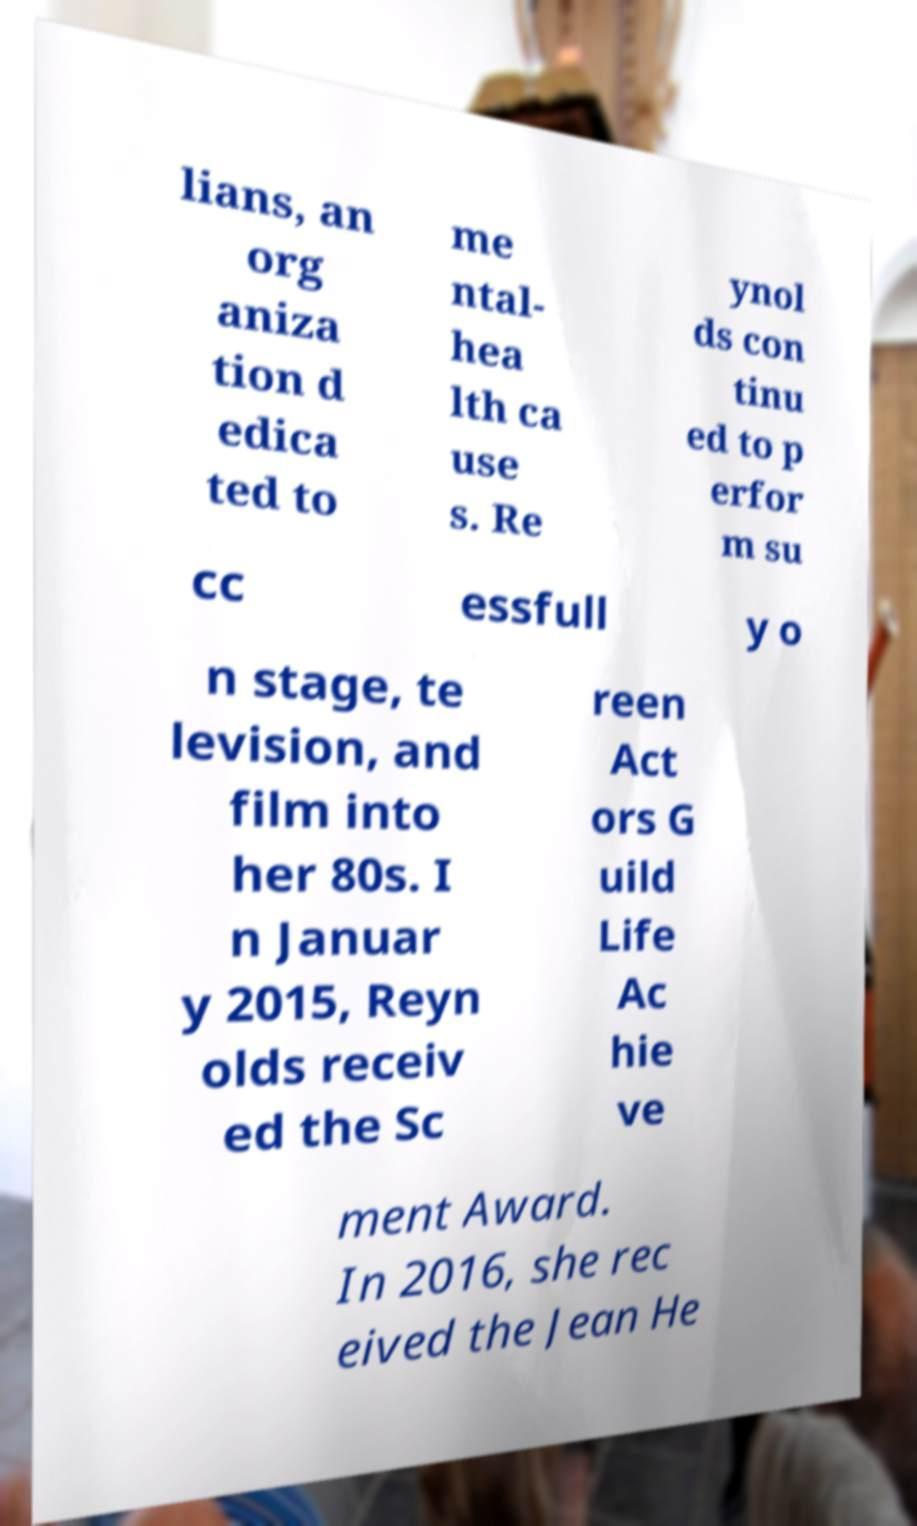I need the written content from this picture converted into text. Can you do that? lians, an org aniza tion d edica ted to me ntal- hea lth ca use s. Re ynol ds con tinu ed to p erfor m su cc essfull y o n stage, te levision, and film into her 80s. I n Januar y 2015, Reyn olds receiv ed the Sc reen Act ors G uild Life Ac hie ve ment Award. In 2016, she rec eived the Jean He 